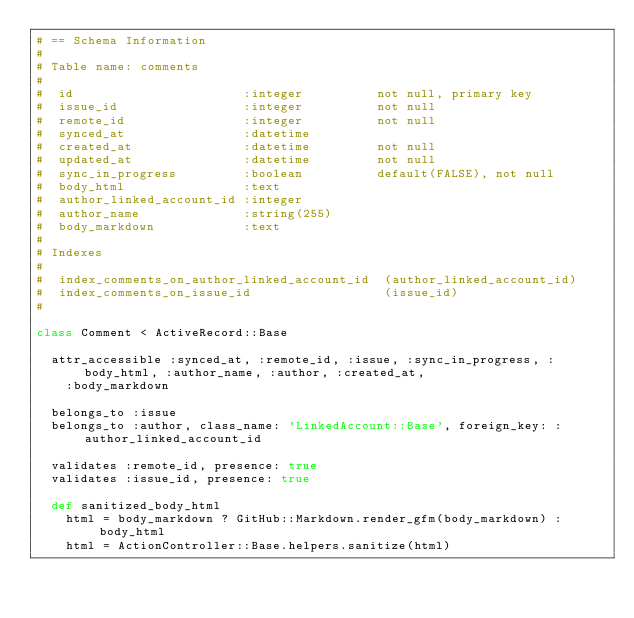<code> <loc_0><loc_0><loc_500><loc_500><_Ruby_># == Schema Information
#
# Table name: comments
#
#  id                       :integer          not null, primary key
#  issue_id                 :integer          not null
#  remote_id                :integer          not null
#  synced_at                :datetime
#  created_at               :datetime         not null
#  updated_at               :datetime         not null
#  sync_in_progress         :boolean          default(FALSE), not null
#  body_html                :text
#  author_linked_account_id :integer
#  author_name              :string(255)
#  body_markdown            :text
#
# Indexes
#
#  index_comments_on_author_linked_account_id  (author_linked_account_id)
#  index_comments_on_issue_id                  (issue_id)
#

class Comment < ActiveRecord::Base

  attr_accessible :synced_at, :remote_id, :issue, :sync_in_progress, :body_html, :author_name, :author, :created_at,
    :body_markdown

  belongs_to :issue
  belongs_to :author, class_name: 'LinkedAccount::Base', foreign_key: :author_linked_account_id

  validates :remote_id, presence: true
  validates :issue_id, presence: true

  def sanitized_body_html
    html = body_markdown ? GitHub::Markdown.render_gfm(body_markdown) : body_html
    html = ActionController::Base.helpers.sanitize(html)</code> 